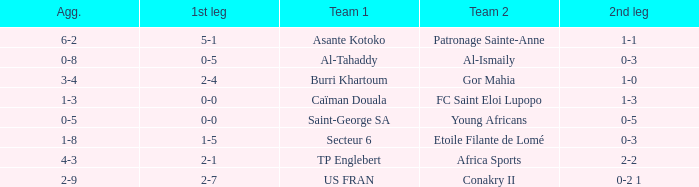Which teams had an aggregate score of 3-4? Burri Khartoum. 